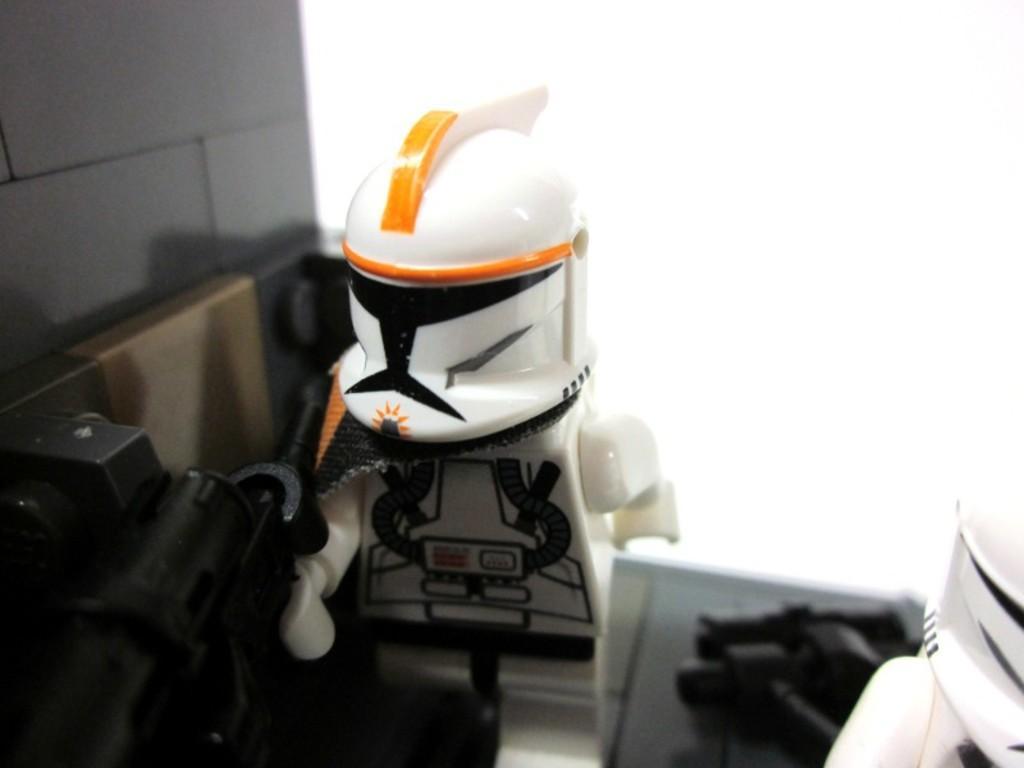Describe this image in one or two sentences. In this image there are toys. To the left side of the image there is a wall. 